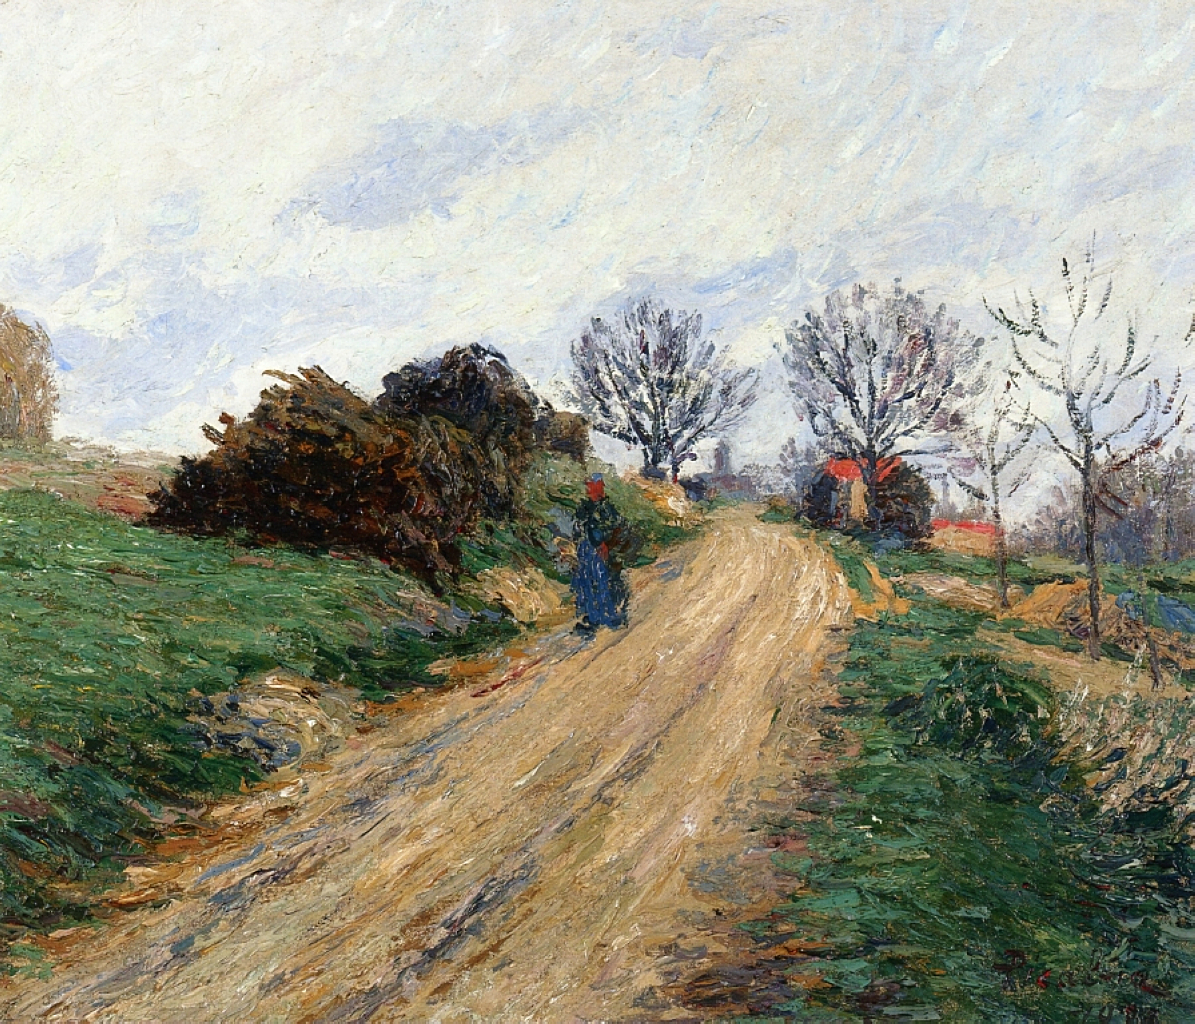What might be the story behind this painting? The painting could tell the story of a solitary walk in the countryside, possibly by a local villager heading home after a day of work or running errands. The figure on the road, though small and not detailed, adds a personal touch, suggesting a moment of introspection as they walk along the tree-lined path. The houses in the distance hint at a close-knit community, where each home holds its own stories and histories. The scene captures a moment of quietude and reflection, characteristic of rural living. Describe the technique the artist might have used to create such an atmosphere. The artist likely used the impressionist technique to create such a serene and nostalgic atmosphere. This involves applying loose, visible brush strokes to capture the essence of the scene rather than focusing on fine details. The use of a muted color palette, with gentle transitions between shades, helps in building a calm and cohesive image. The interplay of light is captured through varying tones, giving the landscape a dynamic yet peaceful look. Additionally, the artist may have painted en plein air (outdoors) to capture the natural light and atmospheric conditions authentically. Imagine the image takes place in a fantastical world, what magical elements could be added to this scene? In a fantastical world, the scene could be transformed in numerous whimsical ways. The trees lining the road could be enchanted, perhaps with glowing leaves that change colors as the viewer watches, creating a rainbow canopy. The dirt road might be paved with cobblestones that shimmer with hints of embedded precious gems. The distant houses could morph into quaint cottages with ivy that blossoms with sparkling flowers under a magical moonlight.

Adding mythical creatures to the scene would enhance its magical aura—perhaps small fairies fluttering around, leaving trails of glowing dust in their wake, or a majestic unicorn grazing among the bushes. The sky could shift into a mesmerizing twilight, painted with shades of pink, purple, and gold, interspersed with stars that twinkle brightly even during the day. These elements would turn the tranquil, rural landscape into an enchanting, dreamlike realm filled with wonder and delight. 